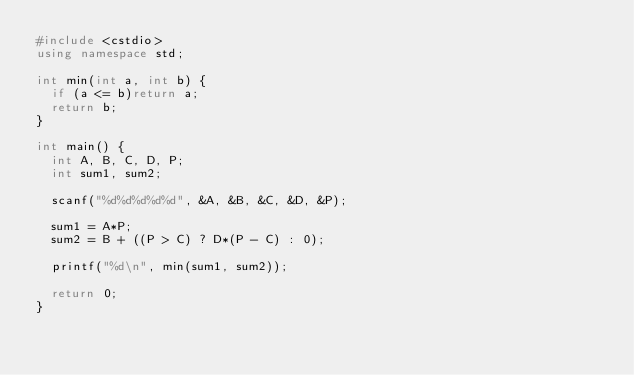<code> <loc_0><loc_0><loc_500><loc_500><_C++_>#include <cstdio>
using namespace std;

int min(int a, int b) {
	if (a <= b)return a;
	return b;
}

int main() {
	int A, B, C, D, P;
	int sum1, sum2;

	scanf("%d%d%d%d%d", &A, &B, &C, &D, &P);

	sum1 = A*P;
	sum2 = B + ((P > C) ? D*(P - C) : 0);

	printf("%d\n", min(sum1, sum2));

	return 0;
}</code> 